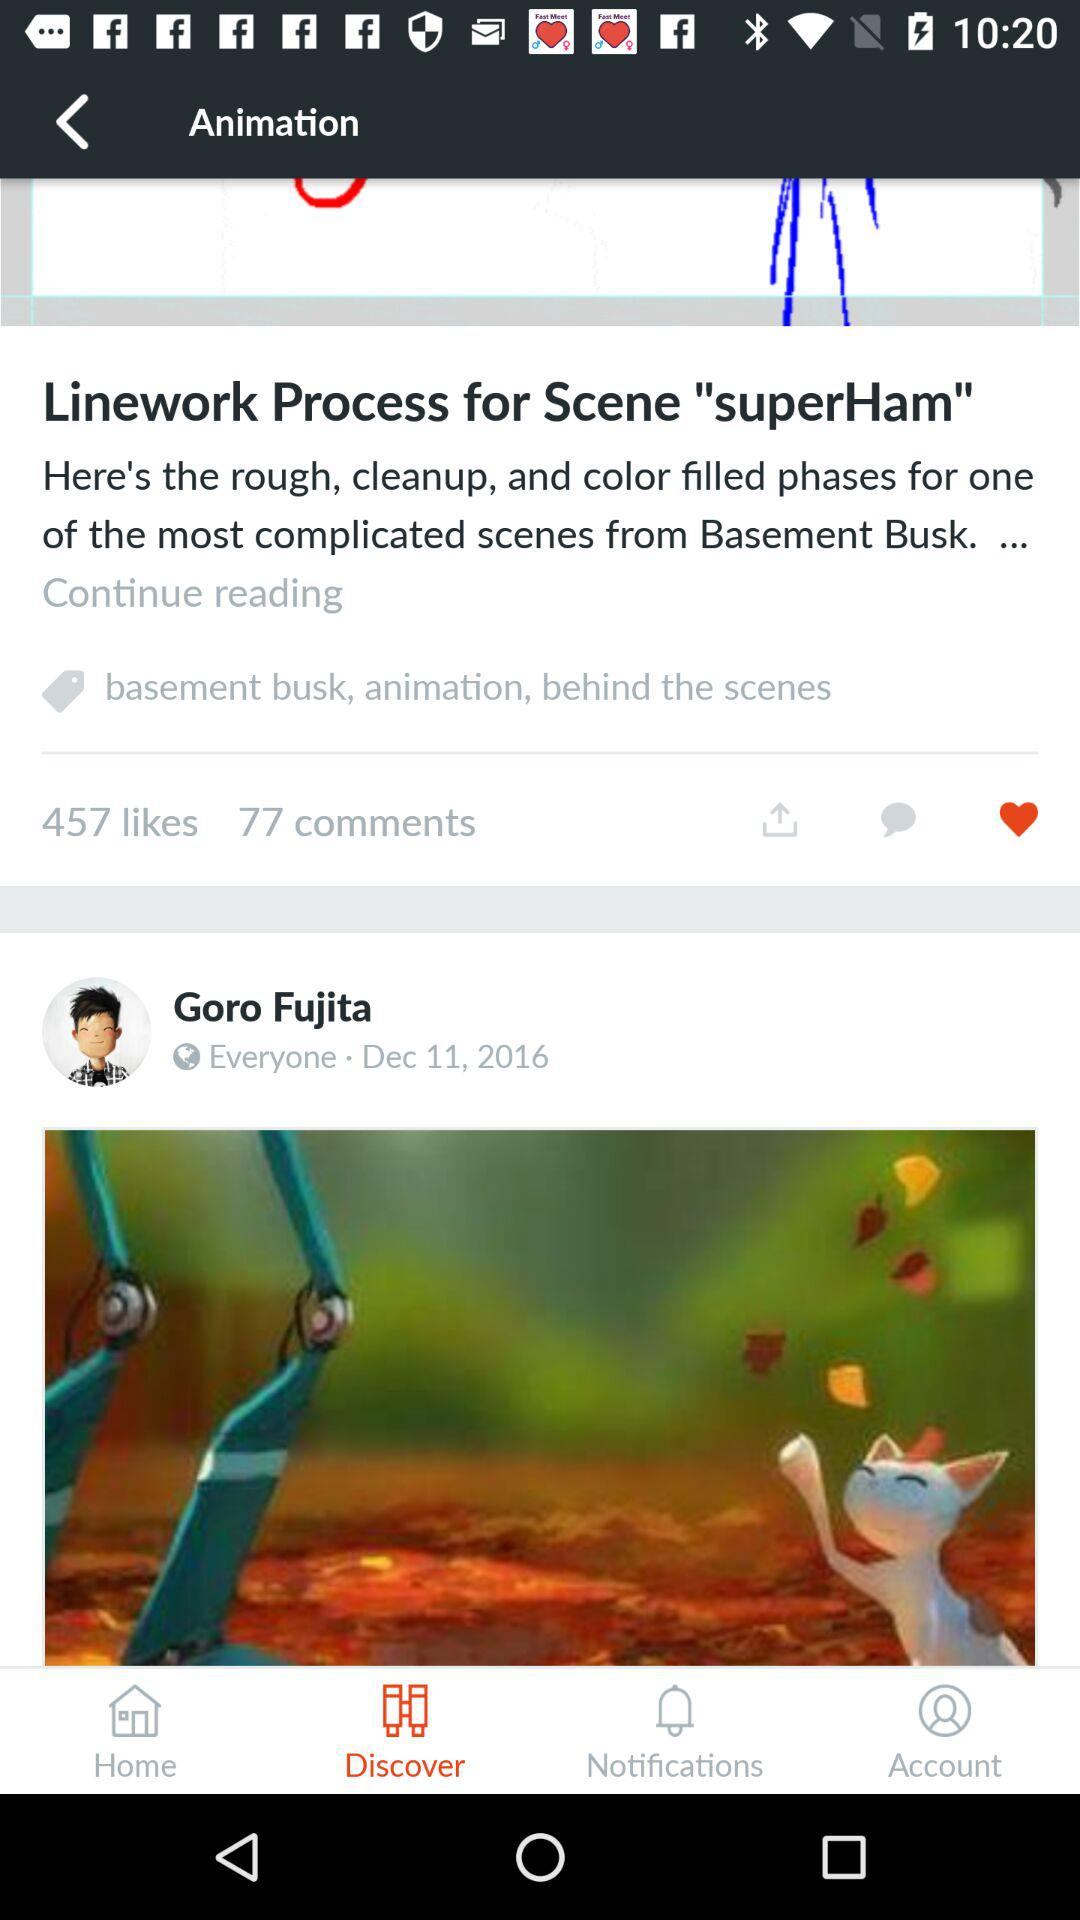Which is the selected tab? The selected tab is "Discover". 